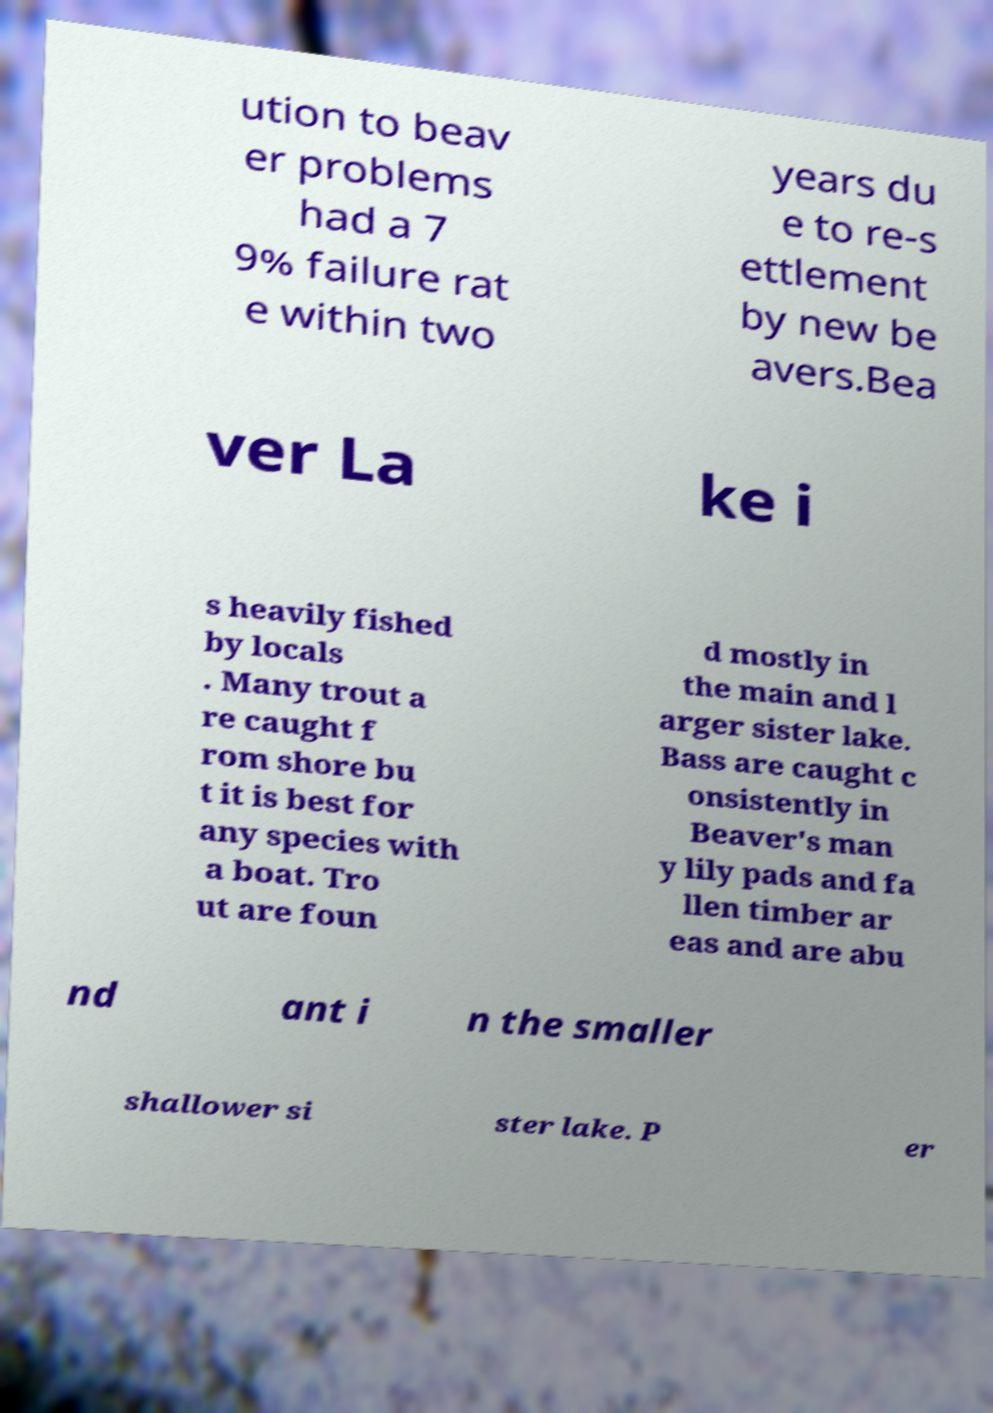What messages or text are displayed in this image? I need them in a readable, typed format. ution to beav er problems had a 7 9% failure rat e within two years du e to re-s ettlement by new be avers.Bea ver La ke i s heavily fished by locals . Many trout a re caught f rom shore bu t it is best for any species with a boat. Tro ut are foun d mostly in the main and l arger sister lake. Bass are caught c onsistently in Beaver's man y lily pads and fa llen timber ar eas and are abu nd ant i n the smaller shallower si ster lake. P er 